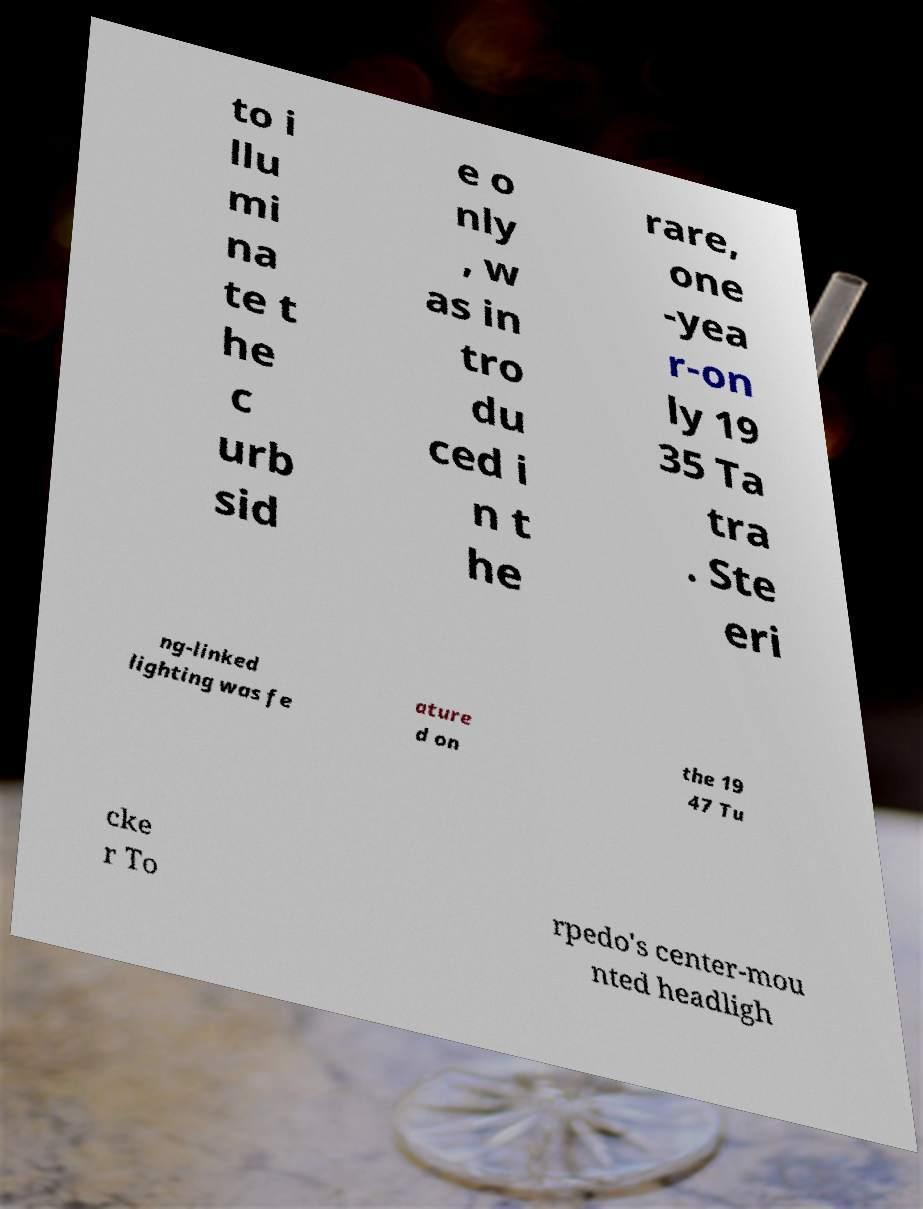Could you assist in decoding the text presented in this image and type it out clearly? to i llu mi na te t he c urb sid e o nly , w as in tro du ced i n t he rare, one -yea r-on ly 19 35 Ta tra . Ste eri ng-linked lighting was fe ature d on the 19 47 Tu cke r To rpedo's center-mou nted headligh 